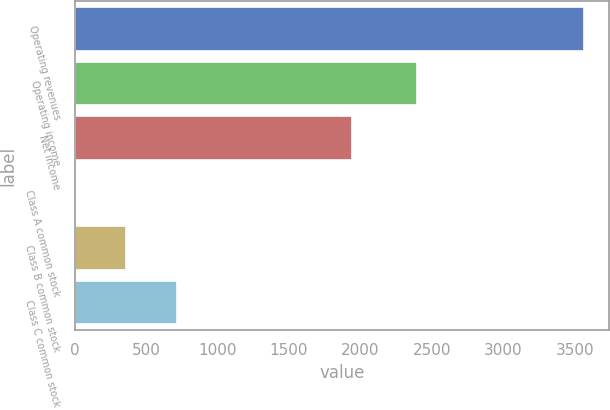Convert chart. <chart><loc_0><loc_0><loc_500><loc_500><bar_chart><fcel>Operating revenues<fcel>Operating income<fcel>Net income<fcel>Class A common stock<fcel>Class B common stock<fcel>Class C common stock<nl><fcel>3565<fcel>2396<fcel>1941<fcel>0.8<fcel>357.22<fcel>713.64<nl></chart> 